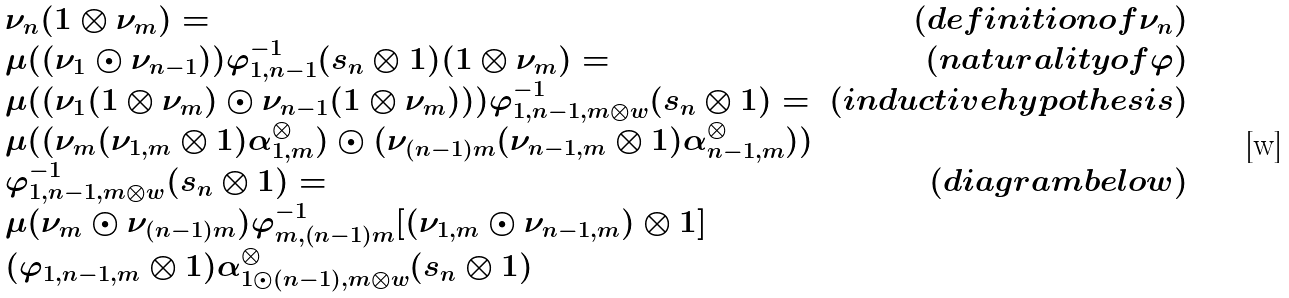<formula> <loc_0><loc_0><loc_500><loc_500>\begin{array} { l r } \nu _ { n } ( 1 \otimes \nu _ { m } ) = & ( d e f i n i t i o n o f \nu _ { n } ) \\ \mu ( ( \nu _ { 1 } \odot \nu _ { n - 1 } ) ) \varphi _ { 1 , n - 1 } ^ { - 1 } ( s _ { n } \otimes 1 ) ( 1 \otimes \nu _ { m } ) = & ( n a t u r a l i t y o f \varphi ) \\ \mu ( ( \nu _ { 1 } ( 1 \otimes \nu _ { m } ) \odot \nu _ { n - 1 } ( 1 \otimes \nu _ { m } ) ) ) \varphi _ { 1 , n - 1 , m \otimes w } ^ { - 1 } ( s _ { n } \otimes 1 ) = & ( i n d u c t i v e h y p o t h e s i s ) \\ \mu ( ( \nu _ { m } ( \nu _ { 1 , m } \otimes 1 ) \alpha _ { 1 , m } ^ { \otimes } ) \odot ( \nu _ { ( n - 1 ) m } ( \nu _ { n - 1 , m } \otimes 1 ) \alpha _ { n - 1 , m } ^ { \otimes } ) ) \\ \varphi _ { 1 , n - 1 , m \otimes w } ^ { - 1 } ( s _ { n } \otimes 1 ) = & ( d i a g r a m b e l o w ) \\ \mu ( \nu _ { m } \odot \nu _ { ( n - 1 ) m } ) \varphi _ { m , ( n - 1 ) m } ^ { - 1 } [ ( \nu _ { 1 , m } \odot \nu _ { n - 1 , m } ) \otimes 1 ] \\ ( \varphi _ { 1 , n - 1 , m } \otimes 1 ) \alpha _ { 1 \odot ( n - 1 ) , m \otimes w } ^ { \otimes } ( s _ { n } \otimes 1 ) \end{array}</formula> 